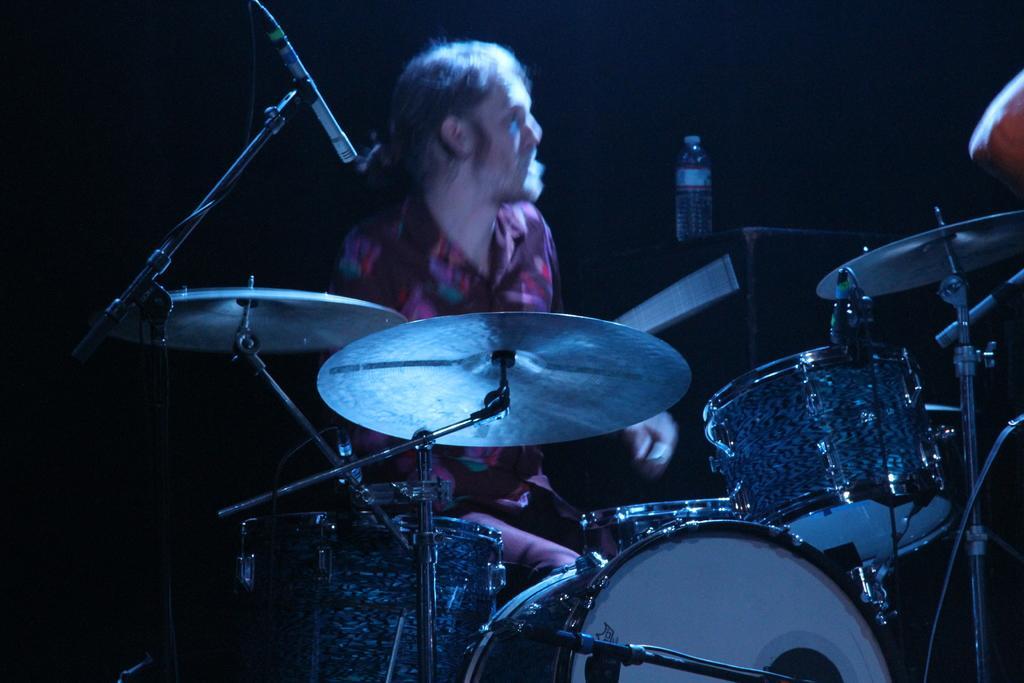Describe this image in one or two sentences. In this picture, there is a man wearing a red shirt and he is playing drums. Beside him, there is a bottle and the background is black. 